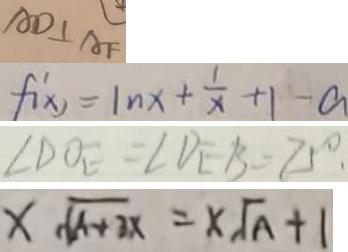<formula> <loc_0><loc_0><loc_500><loc_500>A D \bot A F 
 f ^ { \prime } ( x ) = \ln x + \frac { 1 } { x } + 1 - a 
 \angle D O E = \angle D E B = 7 5 ^ { \circ } . 
 x \sqrt { A + 3 x } = x \sqrt { A } + 1</formula> 